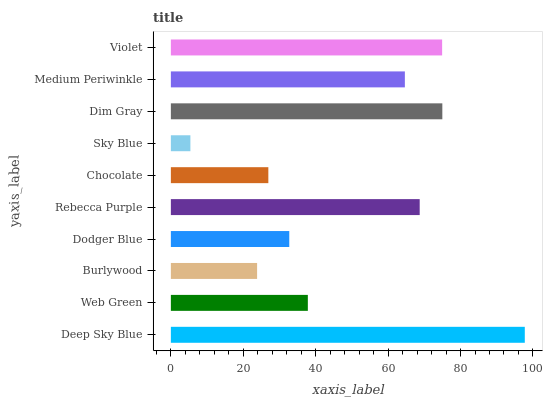Is Sky Blue the minimum?
Answer yes or no. Yes. Is Deep Sky Blue the maximum?
Answer yes or no. Yes. Is Web Green the minimum?
Answer yes or no. No. Is Web Green the maximum?
Answer yes or no. No. Is Deep Sky Blue greater than Web Green?
Answer yes or no. Yes. Is Web Green less than Deep Sky Blue?
Answer yes or no. Yes. Is Web Green greater than Deep Sky Blue?
Answer yes or no. No. Is Deep Sky Blue less than Web Green?
Answer yes or no. No. Is Medium Periwinkle the high median?
Answer yes or no. Yes. Is Web Green the low median?
Answer yes or no. Yes. Is Deep Sky Blue the high median?
Answer yes or no. No. Is Deep Sky Blue the low median?
Answer yes or no. No. 